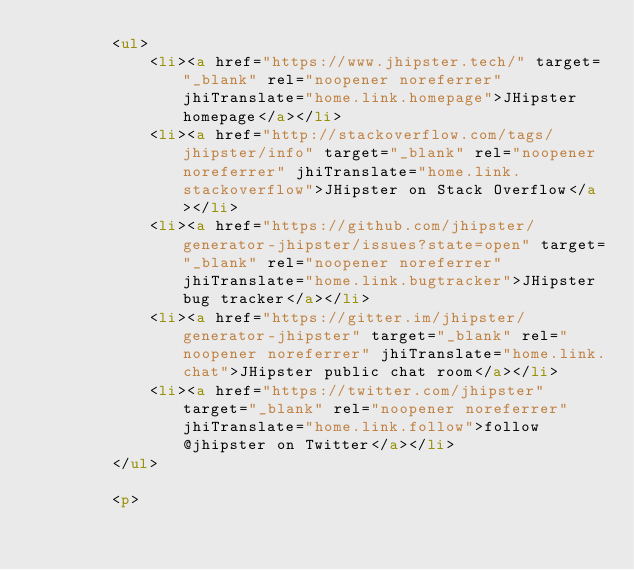Convert code to text. <code><loc_0><loc_0><loc_500><loc_500><_HTML_>        <ul>
            <li><a href="https://www.jhipster.tech/" target="_blank" rel="noopener noreferrer" jhiTranslate="home.link.homepage">JHipster homepage</a></li>
            <li><a href="http://stackoverflow.com/tags/jhipster/info" target="_blank" rel="noopener noreferrer" jhiTranslate="home.link.stackoverflow">JHipster on Stack Overflow</a></li>
            <li><a href="https://github.com/jhipster/generator-jhipster/issues?state=open" target="_blank" rel="noopener noreferrer" jhiTranslate="home.link.bugtracker">JHipster bug tracker</a></li>
            <li><a href="https://gitter.im/jhipster/generator-jhipster" target="_blank" rel="noopener noreferrer" jhiTranslate="home.link.chat">JHipster public chat room</a></li>
            <li><a href="https://twitter.com/jhipster" target="_blank" rel="noopener noreferrer" jhiTranslate="home.link.follow">follow @jhipster on Twitter</a></li>
        </ul>

        <p></code> 